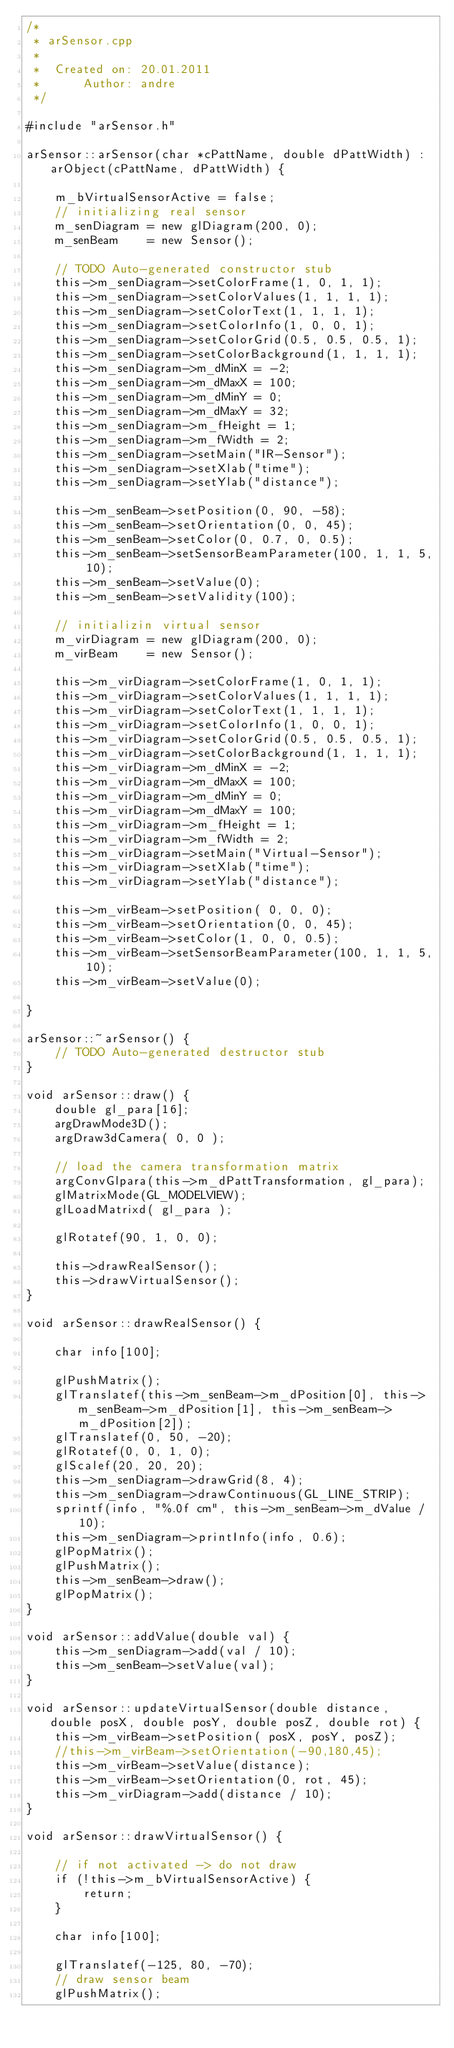Convert code to text. <code><loc_0><loc_0><loc_500><loc_500><_C++_>/*
 * arSensor.cpp
 *
 *  Created on: 20.01.2011
 *      Author: andre
 */

#include "arSensor.h"

arSensor::arSensor(char *cPattName, double dPattWidth) : arObject(cPattName, dPattWidth) {

    m_bVirtualSensorActive = false;
    // initializing real sensor
    m_senDiagram = new glDiagram(200, 0);
    m_senBeam    = new Sensor();

    // TODO Auto-generated constructor stub
    this->m_senDiagram->setColorFrame(1, 0, 1, 1);
    this->m_senDiagram->setColorValues(1, 1, 1, 1);
    this->m_senDiagram->setColorText(1, 1, 1, 1);
    this->m_senDiagram->setColorInfo(1, 0, 0, 1);
    this->m_senDiagram->setColorGrid(0.5, 0.5, 0.5, 1);
    this->m_senDiagram->setColorBackground(1, 1, 1, 1);
    this->m_senDiagram->m_dMinX = -2;
    this->m_senDiagram->m_dMaxX = 100;
    this->m_senDiagram->m_dMinY = 0;
    this->m_senDiagram->m_dMaxY = 32;
    this->m_senDiagram->m_fHeight = 1;
    this->m_senDiagram->m_fWidth = 2;
    this->m_senDiagram->setMain("IR-Sensor");
    this->m_senDiagram->setXlab("time");
    this->m_senDiagram->setYlab("distance");

    this->m_senBeam->setPosition(0, 90, -58);
    this->m_senBeam->setOrientation(0, 0, 45);
    this->m_senBeam->setColor(0, 0.7, 0, 0.5);
    this->m_senBeam->setSensorBeamParameter(100, 1, 1, 5, 10);
    this->m_senBeam->setValue(0);
    this->m_senBeam->setValidity(100);

    // initializin virtual sensor
    m_virDiagram = new glDiagram(200, 0);
    m_virBeam    = new Sensor();

    this->m_virDiagram->setColorFrame(1, 0, 1, 1);
    this->m_virDiagram->setColorValues(1, 1, 1, 1);
    this->m_virDiagram->setColorText(1, 1, 1, 1);
    this->m_virDiagram->setColorInfo(1, 0, 0, 1);
    this->m_virDiagram->setColorGrid(0.5, 0.5, 0.5, 1);
    this->m_virDiagram->setColorBackground(1, 1, 1, 1);
    this->m_virDiagram->m_dMinX = -2;
    this->m_virDiagram->m_dMaxX = 100;
    this->m_virDiagram->m_dMinY = 0;
    this->m_virDiagram->m_dMaxY = 100;
    this->m_virDiagram->m_fHeight = 1;
    this->m_virDiagram->m_fWidth = 2;
    this->m_virDiagram->setMain("Virtual-Sensor");
    this->m_virDiagram->setXlab("time");
    this->m_virDiagram->setYlab("distance");

    this->m_virBeam->setPosition( 0, 0, 0);
    this->m_virBeam->setOrientation(0, 0, 45);
    this->m_virBeam->setColor(1, 0, 0, 0.5);
    this->m_virBeam->setSensorBeamParameter(100, 1, 1, 5, 10);
    this->m_virBeam->setValue(0);

}

arSensor::~arSensor() {
    // TODO Auto-generated destructor stub
}

void arSensor::draw() {
    double gl_para[16];
    argDrawMode3D();
    argDraw3dCamera( 0, 0 );

    // load the camera transformation matrix
    argConvGlpara(this->m_dPattTransformation, gl_para);
    glMatrixMode(GL_MODELVIEW);
    glLoadMatrixd( gl_para );

    glRotatef(90, 1, 0, 0);

    this->drawRealSensor();
    this->drawVirtualSensor();
}

void arSensor::drawRealSensor() {

    char info[100];

    glPushMatrix();
    glTranslatef(this->m_senBeam->m_dPosition[0], this->m_senBeam->m_dPosition[1], this->m_senBeam->m_dPosition[2]);
    glTranslatef(0, 50, -20);
    glRotatef(0, 0, 1, 0);
    glScalef(20, 20, 20);
    this->m_senDiagram->drawGrid(8, 4);
    this->m_senDiagram->drawContinuous(GL_LINE_STRIP);
    sprintf(info, "%.0f cm", this->m_senBeam->m_dValue / 10);
    this->m_senDiagram->printInfo(info, 0.6);
    glPopMatrix();
    glPushMatrix();
    this->m_senBeam->draw();
    glPopMatrix();
}

void arSensor::addValue(double val) {
    this->m_senDiagram->add(val / 10);
    this->m_senBeam->setValue(val);
}

void arSensor::updateVirtualSensor(double distance, double posX, double posY, double posZ, double rot) {
    this->m_virBeam->setPosition( posX, posY, posZ);
    //this->m_virBeam->setOrientation(-90,180,45);
    this->m_virBeam->setValue(distance);
    this->m_virBeam->setOrientation(0, rot, 45);
    this->m_virDiagram->add(distance / 10);
}

void arSensor::drawVirtualSensor() {

    // if not activated -> do not draw
    if (!this->m_bVirtualSensorActive) {
        return;
    }

    char info[100];

    glTranslatef(-125, 80, -70);
    // draw sensor beam
    glPushMatrix();</code> 